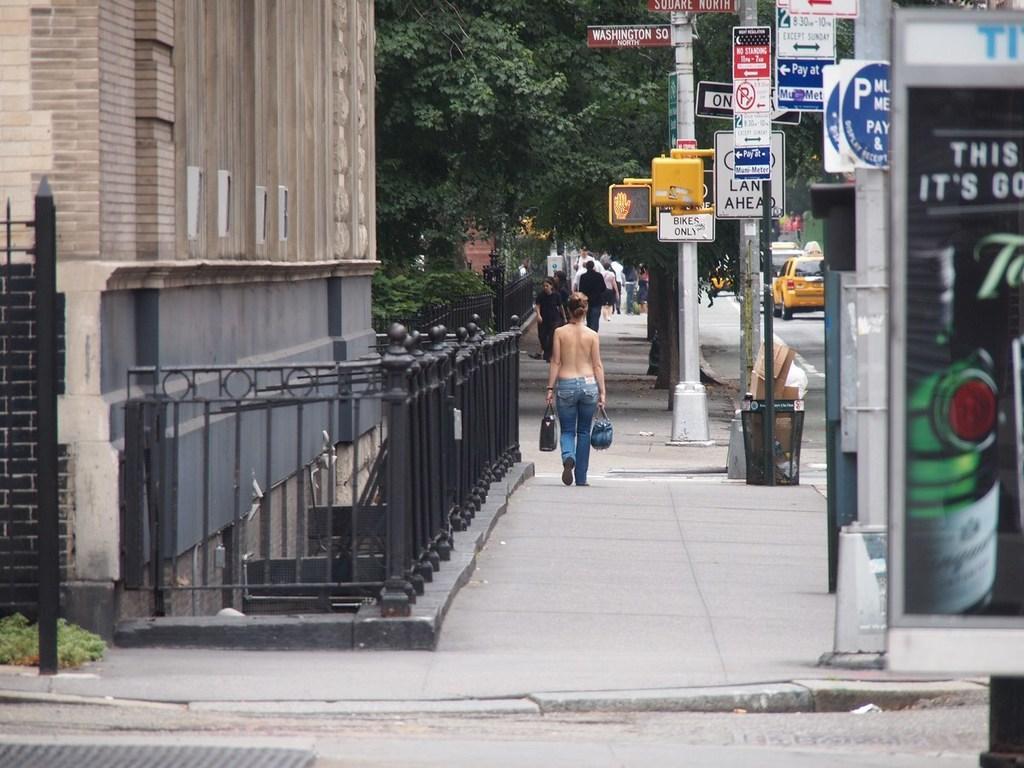In one or two sentences, can you explain what this image depicts? In this image I can see people among them this woman is holding some objects in hands. Here I can see buildings, fence, poles which has boards. I can also see vehicles on the road and trees. 